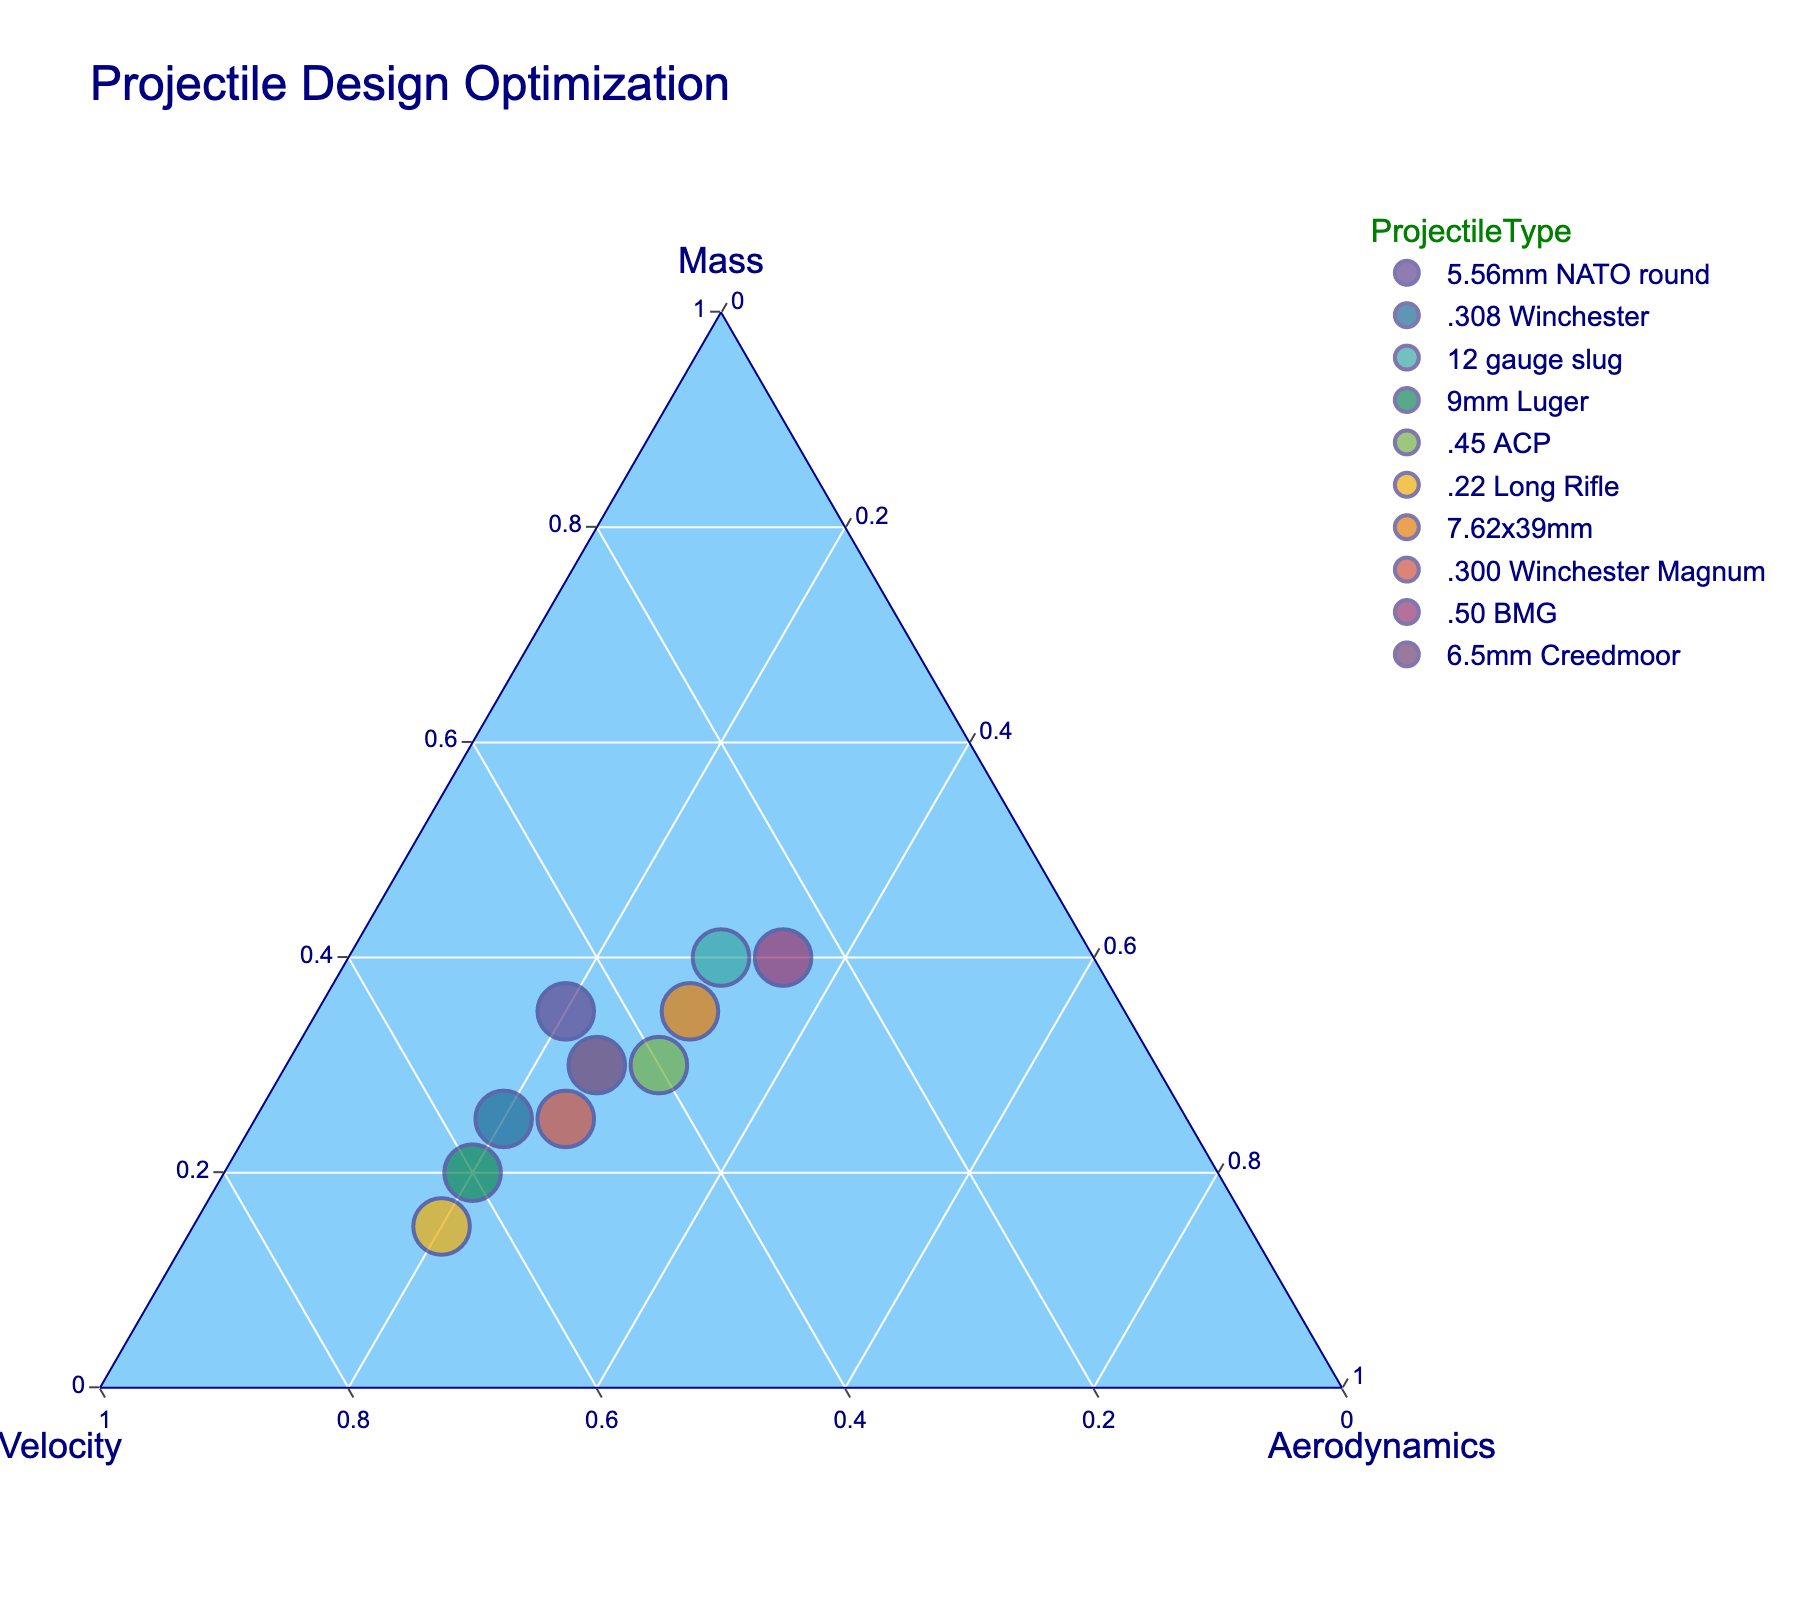What is the title of the ternary plot? The title is displayed prominently at the top of the plot. It reads "Projectile Design Optimization."
Answer: Projectile Design Optimization How many projectile types are represented in the plot? The plot contains data points, each labeled with a unique projectile type. By counting these labels, we can see there are 10 different projectile types.
Answer: 10 Which projectile type has the highest velocity? In a ternary plot, the vertex representing velocity will have points closest to it, indicating high values. The 9mm Luger is closest to the velocity vertex.
Answer: 9mm Luger Which projectile type appears to have a nearly balanced distribution of mass, velocity, and aerodynamics? A balanced distribution of mass, velocity, and aerodynamics will be represented by a point near the center of the ternary plot. The 7.62x39mm appears near the center.
Answer: 7.62x39mm Which projectile types have an aerodynamics value of 0.30? In a ternary plot, points along lines parallel to the axis for aerodynamics that intersect at 0.30 indicate projectiles with an aerodynamics value of 0.30. There are three such types: 12 gauge slug, .45 ACP, and 7.62x39mm.
Answer: 12 gauge slug, .45 ACP, 7.62x39mm Compare the mass and velocity of the 5.56mm NATO round and the .308 Winchester. Which has a higher mass, and which has a higher velocity? By identifying each projectile type on the plot: the 5.56mm NATO round is closer to the mass axis (higher mass), and the .308 Winchester is closer to the velocity axis (higher velocity).
Answer: 5.56mm NATO round: higher mass; .308 Winchester: higher velocity If the sum of mass and aerodynamics for each projectile type is calculated, which one has the highest sum? The sum of mass and aerodynamics is determined by adding the values for each type. The .50 BMG has the highest sum with a mass of 0.40 and an aerodynamics value of 0.35, totaling 0.75.
Answer: .50 BMG In terms of mass, which projectile type lies exactly between the .300 Winchester Magnum and the 6.5mm Creedmoor? The mass values can be derived from the plot: .300 Winchester Magnum has a mass of 0.25 and 6.5mm Creedmoor has a mass of 0.30. The .45 ACP, with a mass value of 0.30, lies between these two.
Answer: .45 ACP Identify the projectile type with the lowest value for mass and list its corresponding values for velocity and aerodynamics. The lowest mass value is observed closer to the velocity axis. The .22 Long Rifle has the lowest mass of 0.15, with corresponding velocity and aerodynamics values of 0.65 and 0.20.
Answer: .22 Long Rifle: Velocity: 0.65, Aerodynamics: 0.20 